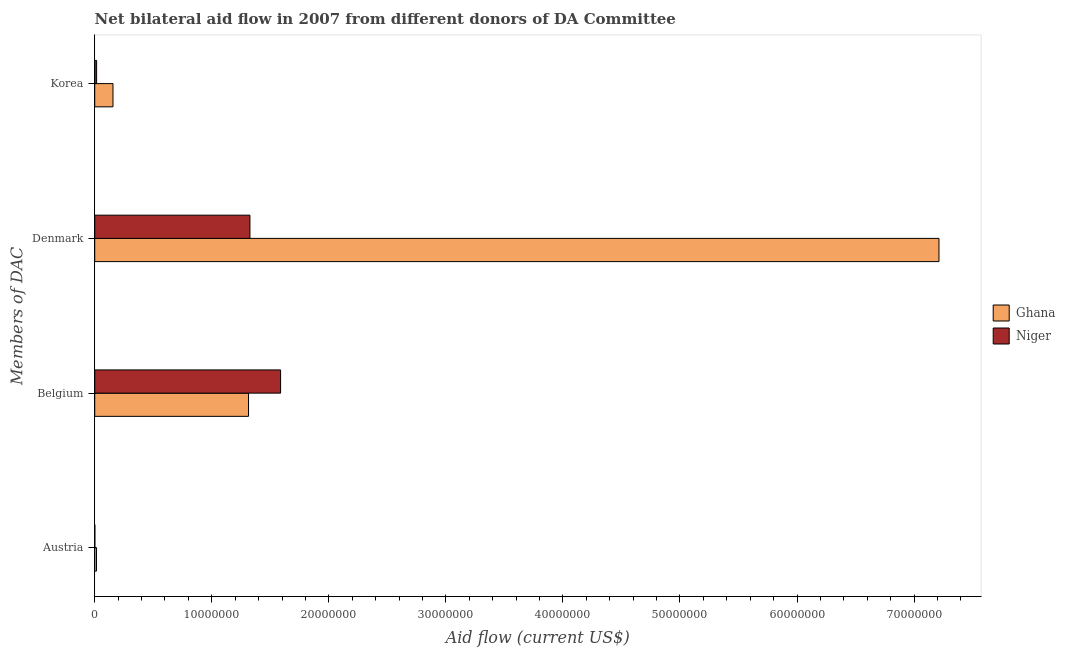How many different coloured bars are there?
Keep it short and to the point. 2. Are the number of bars on each tick of the Y-axis equal?
Give a very brief answer. Yes. How many bars are there on the 3rd tick from the bottom?
Make the answer very short. 2. What is the amount of aid given by austria in Niger?
Your answer should be very brief. 10000. Across all countries, what is the maximum amount of aid given by belgium?
Ensure brevity in your answer.  1.59e+07. Across all countries, what is the minimum amount of aid given by denmark?
Give a very brief answer. 1.33e+07. In which country was the amount of aid given by denmark maximum?
Give a very brief answer. Ghana. In which country was the amount of aid given by denmark minimum?
Keep it short and to the point. Niger. What is the total amount of aid given by belgium in the graph?
Your response must be concise. 2.90e+07. What is the difference between the amount of aid given by austria in Niger and that in Ghana?
Offer a terse response. -1.40e+05. What is the difference between the amount of aid given by austria in Niger and the amount of aid given by denmark in Ghana?
Your answer should be compact. -7.21e+07. What is the average amount of aid given by denmark per country?
Keep it short and to the point. 4.27e+07. What is the difference between the amount of aid given by korea and amount of aid given by austria in Ghana?
Give a very brief answer. 1.41e+06. In how many countries, is the amount of aid given by korea greater than 46000000 US$?
Ensure brevity in your answer.  0. What is the ratio of the amount of aid given by denmark in Ghana to that in Niger?
Offer a terse response. 5.44. Is the difference between the amount of aid given by denmark in Niger and Ghana greater than the difference between the amount of aid given by korea in Niger and Ghana?
Offer a very short reply. No. What is the difference between the highest and the second highest amount of aid given by korea?
Your response must be concise. 1.40e+06. What is the difference between the highest and the lowest amount of aid given by belgium?
Provide a succinct answer. 2.74e+06. Is the sum of the amount of aid given by austria in Niger and Ghana greater than the maximum amount of aid given by denmark across all countries?
Offer a terse response. No. Is it the case that in every country, the sum of the amount of aid given by korea and amount of aid given by denmark is greater than the sum of amount of aid given by austria and amount of aid given by belgium?
Your response must be concise. Yes. What does the 1st bar from the top in Denmark represents?
Give a very brief answer. Niger. What does the 1st bar from the bottom in Austria represents?
Keep it short and to the point. Ghana. Is it the case that in every country, the sum of the amount of aid given by austria and amount of aid given by belgium is greater than the amount of aid given by denmark?
Offer a very short reply. No. How many bars are there?
Your answer should be compact. 8. How many countries are there in the graph?
Provide a short and direct response. 2. How many legend labels are there?
Your answer should be compact. 2. How are the legend labels stacked?
Offer a terse response. Vertical. What is the title of the graph?
Your response must be concise. Net bilateral aid flow in 2007 from different donors of DA Committee. What is the label or title of the Y-axis?
Keep it short and to the point. Members of DAC. What is the Aid flow (current US$) in Ghana in Austria?
Keep it short and to the point. 1.50e+05. What is the Aid flow (current US$) of Ghana in Belgium?
Provide a short and direct response. 1.31e+07. What is the Aid flow (current US$) in Niger in Belgium?
Offer a terse response. 1.59e+07. What is the Aid flow (current US$) in Ghana in Denmark?
Keep it short and to the point. 7.21e+07. What is the Aid flow (current US$) in Niger in Denmark?
Give a very brief answer. 1.33e+07. What is the Aid flow (current US$) in Ghana in Korea?
Offer a very short reply. 1.56e+06. What is the Aid flow (current US$) in Niger in Korea?
Offer a very short reply. 1.60e+05. Across all Members of DAC, what is the maximum Aid flow (current US$) in Ghana?
Provide a succinct answer. 7.21e+07. Across all Members of DAC, what is the maximum Aid flow (current US$) of Niger?
Your answer should be very brief. 1.59e+07. Across all Members of DAC, what is the minimum Aid flow (current US$) of Ghana?
Your answer should be compact. 1.50e+05. Across all Members of DAC, what is the minimum Aid flow (current US$) in Niger?
Ensure brevity in your answer.  10000. What is the total Aid flow (current US$) of Ghana in the graph?
Your answer should be compact. 8.70e+07. What is the total Aid flow (current US$) in Niger in the graph?
Provide a short and direct response. 2.93e+07. What is the difference between the Aid flow (current US$) of Ghana in Austria and that in Belgium?
Make the answer very short. -1.30e+07. What is the difference between the Aid flow (current US$) of Niger in Austria and that in Belgium?
Offer a very short reply. -1.59e+07. What is the difference between the Aid flow (current US$) of Ghana in Austria and that in Denmark?
Offer a very short reply. -7.20e+07. What is the difference between the Aid flow (current US$) of Niger in Austria and that in Denmark?
Give a very brief answer. -1.32e+07. What is the difference between the Aid flow (current US$) of Ghana in Austria and that in Korea?
Offer a terse response. -1.41e+06. What is the difference between the Aid flow (current US$) of Niger in Austria and that in Korea?
Keep it short and to the point. -1.50e+05. What is the difference between the Aid flow (current US$) of Ghana in Belgium and that in Denmark?
Your answer should be compact. -5.90e+07. What is the difference between the Aid flow (current US$) of Niger in Belgium and that in Denmark?
Your response must be concise. 2.62e+06. What is the difference between the Aid flow (current US$) of Ghana in Belgium and that in Korea?
Provide a succinct answer. 1.16e+07. What is the difference between the Aid flow (current US$) in Niger in Belgium and that in Korea?
Your answer should be compact. 1.57e+07. What is the difference between the Aid flow (current US$) in Ghana in Denmark and that in Korea?
Keep it short and to the point. 7.06e+07. What is the difference between the Aid flow (current US$) in Niger in Denmark and that in Korea?
Provide a succinct answer. 1.31e+07. What is the difference between the Aid flow (current US$) of Ghana in Austria and the Aid flow (current US$) of Niger in Belgium?
Your response must be concise. -1.57e+07. What is the difference between the Aid flow (current US$) in Ghana in Austria and the Aid flow (current US$) in Niger in Denmark?
Your answer should be compact. -1.31e+07. What is the difference between the Aid flow (current US$) of Ghana in Belgium and the Aid flow (current US$) of Niger in Korea?
Ensure brevity in your answer.  1.30e+07. What is the difference between the Aid flow (current US$) of Ghana in Denmark and the Aid flow (current US$) of Niger in Korea?
Your answer should be compact. 7.20e+07. What is the average Aid flow (current US$) of Ghana per Members of DAC?
Ensure brevity in your answer.  2.17e+07. What is the average Aid flow (current US$) in Niger per Members of DAC?
Your answer should be compact. 7.33e+06. What is the difference between the Aid flow (current US$) in Ghana and Aid flow (current US$) in Niger in Austria?
Your response must be concise. 1.40e+05. What is the difference between the Aid flow (current US$) of Ghana and Aid flow (current US$) of Niger in Belgium?
Your answer should be very brief. -2.74e+06. What is the difference between the Aid flow (current US$) in Ghana and Aid flow (current US$) in Niger in Denmark?
Your response must be concise. 5.89e+07. What is the difference between the Aid flow (current US$) in Ghana and Aid flow (current US$) in Niger in Korea?
Offer a terse response. 1.40e+06. What is the ratio of the Aid flow (current US$) of Ghana in Austria to that in Belgium?
Your response must be concise. 0.01. What is the ratio of the Aid flow (current US$) in Niger in Austria to that in Belgium?
Your response must be concise. 0. What is the ratio of the Aid flow (current US$) in Ghana in Austria to that in Denmark?
Your response must be concise. 0. What is the ratio of the Aid flow (current US$) in Niger in Austria to that in Denmark?
Your answer should be compact. 0. What is the ratio of the Aid flow (current US$) of Ghana in Austria to that in Korea?
Offer a very short reply. 0.1. What is the ratio of the Aid flow (current US$) of Niger in Austria to that in Korea?
Provide a short and direct response. 0.06. What is the ratio of the Aid flow (current US$) of Ghana in Belgium to that in Denmark?
Provide a short and direct response. 0.18. What is the ratio of the Aid flow (current US$) of Niger in Belgium to that in Denmark?
Provide a succinct answer. 1.2. What is the ratio of the Aid flow (current US$) in Ghana in Belgium to that in Korea?
Keep it short and to the point. 8.42. What is the ratio of the Aid flow (current US$) of Niger in Belgium to that in Korea?
Your answer should be very brief. 99.25. What is the ratio of the Aid flow (current US$) of Ghana in Denmark to that in Korea?
Give a very brief answer. 46.24. What is the ratio of the Aid flow (current US$) in Niger in Denmark to that in Korea?
Offer a terse response. 82.88. What is the difference between the highest and the second highest Aid flow (current US$) of Ghana?
Provide a short and direct response. 5.90e+07. What is the difference between the highest and the second highest Aid flow (current US$) of Niger?
Keep it short and to the point. 2.62e+06. What is the difference between the highest and the lowest Aid flow (current US$) of Ghana?
Provide a short and direct response. 7.20e+07. What is the difference between the highest and the lowest Aid flow (current US$) of Niger?
Offer a terse response. 1.59e+07. 